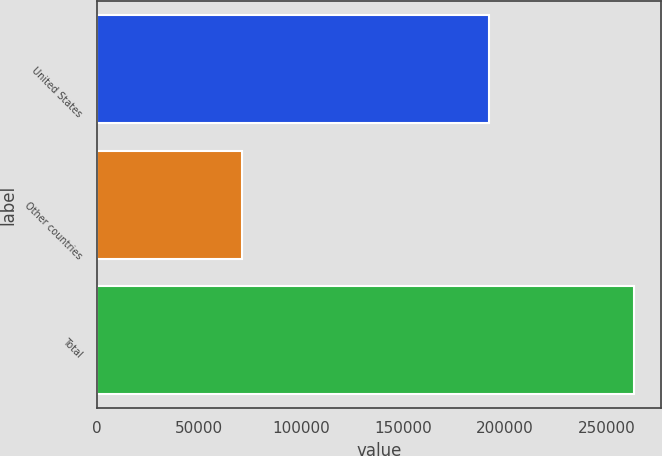Convert chart to OTSL. <chart><loc_0><loc_0><loc_500><loc_500><bar_chart><fcel>United States<fcel>Other countries<fcel>Total<nl><fcel>192075<fcel>71002<fcel>263077<nl></chart> 